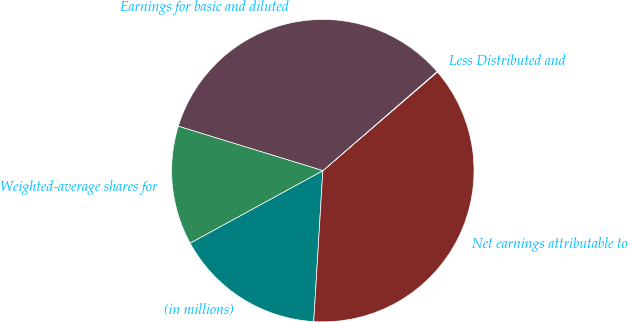Convert chart to OTSL. <chart><loc_0><loc_0><loc_500><loc_500><pie_chart><fcel>(in millions)<fcel>Net earnings attributable to<fcel>Less Distributed and<fcel>Earnings for basic and diluted<fcel>Weighted-average shares for<nl><fcel>16.09%<fcel>37.27%<fcel>0.06%<fcel>33.88%<fcel>12.7%<nl></chart> 